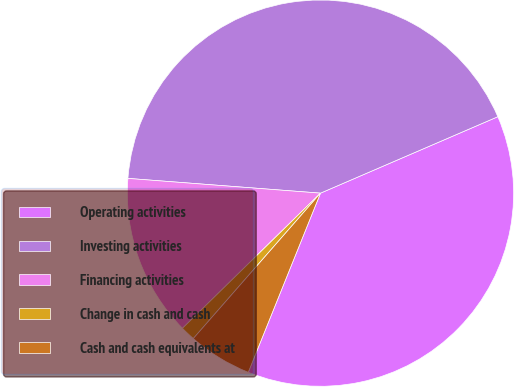Convert chart. <chart><loc_0><loc_0><loc_500><loc_500><pie_chart><fcel>Operating activities<fcel>Investing activities<fcel>Financing activities<fcel>Change in cash and cash<fcel>Cash and cash equivalents at<nl><fcel>37.58%<fcel>42.31%<fcel>13.55%<fcel>1.23%<fcel>5.34%<nl></chart> 